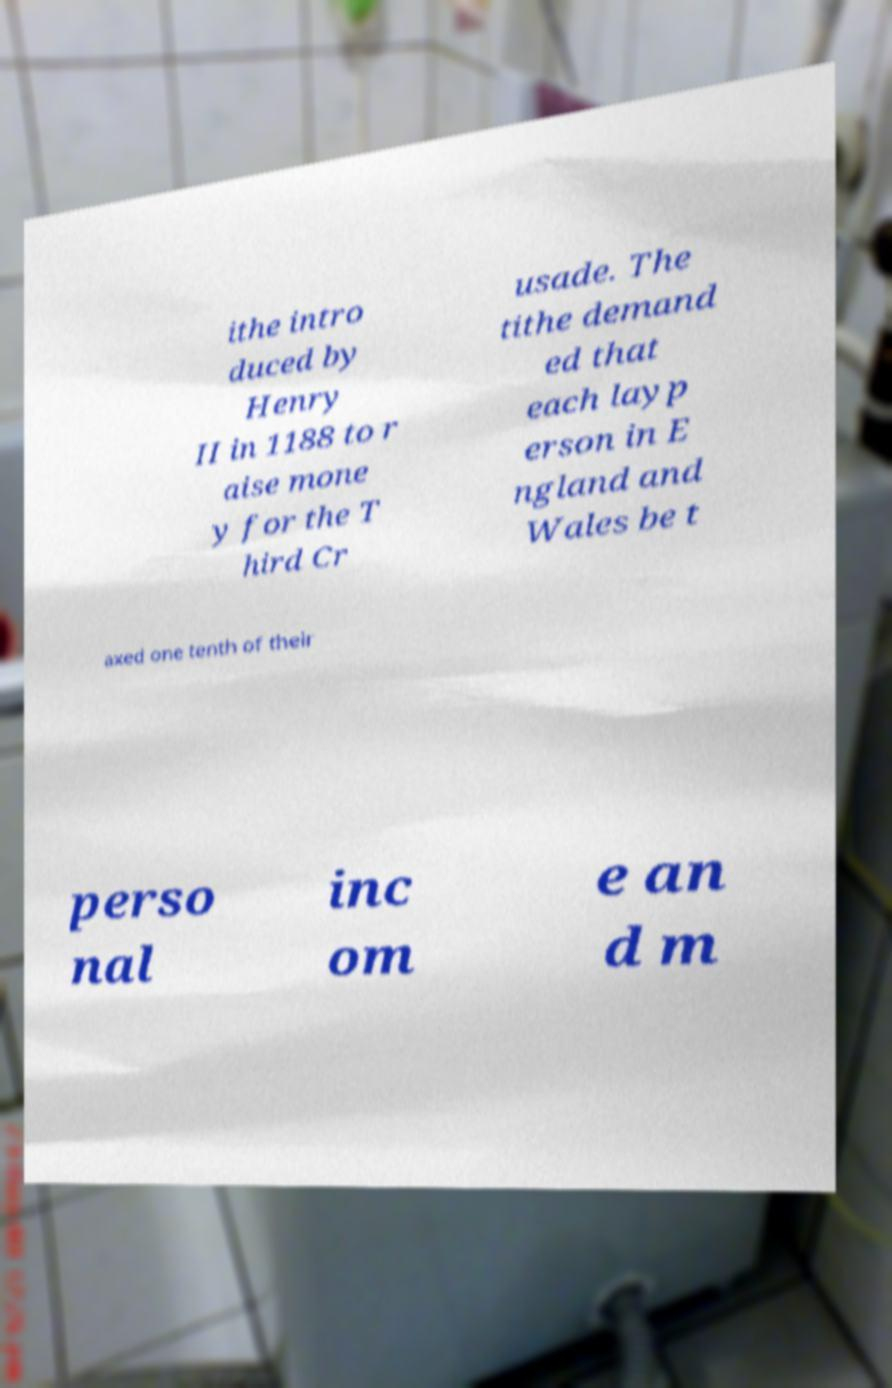Please identify and transcribe the text found in this image. ithe intro duced by Henry II in 1188 to r aise mone y for the T hird Cr usade. The tithe demand ed that each layp erson in E ngland and Wales be t axed one tenth of their perso nal inc om e an d m 